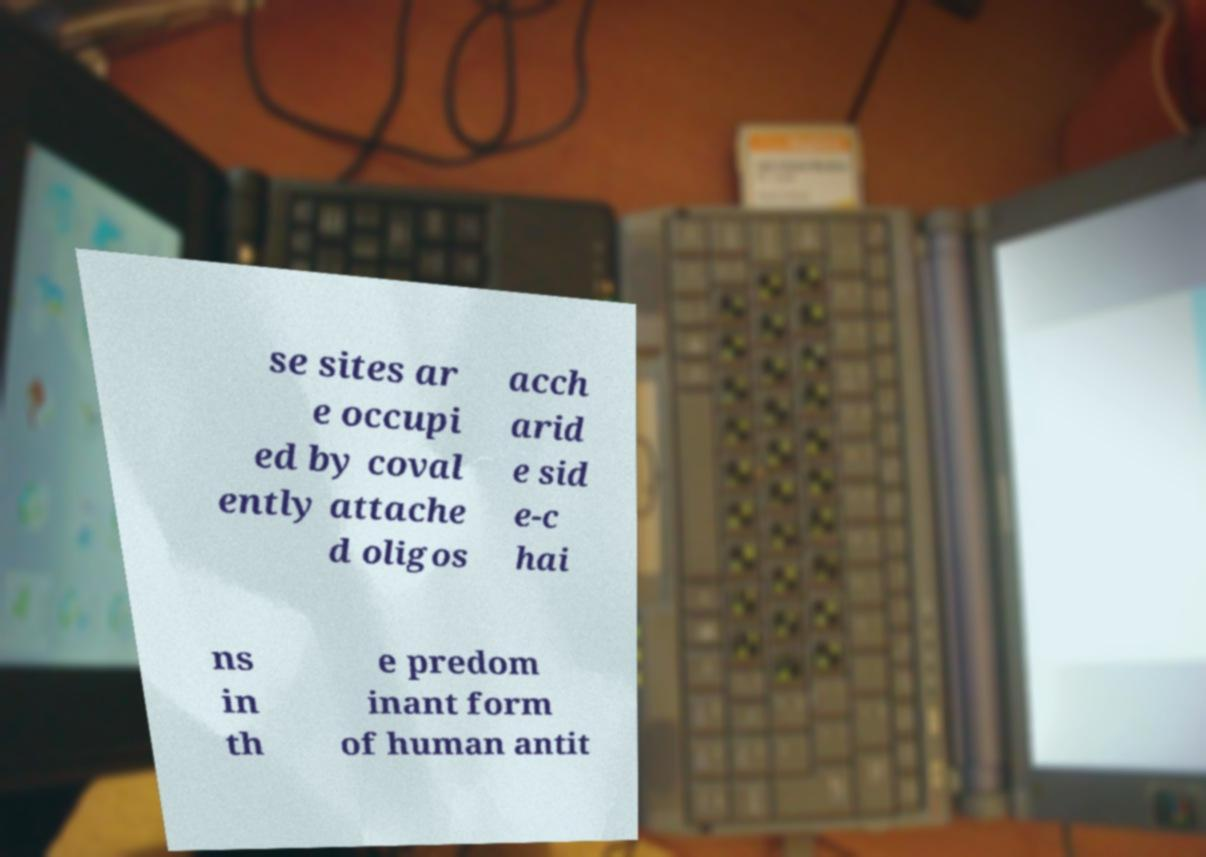Please identify and transcribe the text found in this image. se sites ar e occupi ed by coval ently attache d oligos acch arid e sid e-c hai ns in th e predom inant form of human antit 